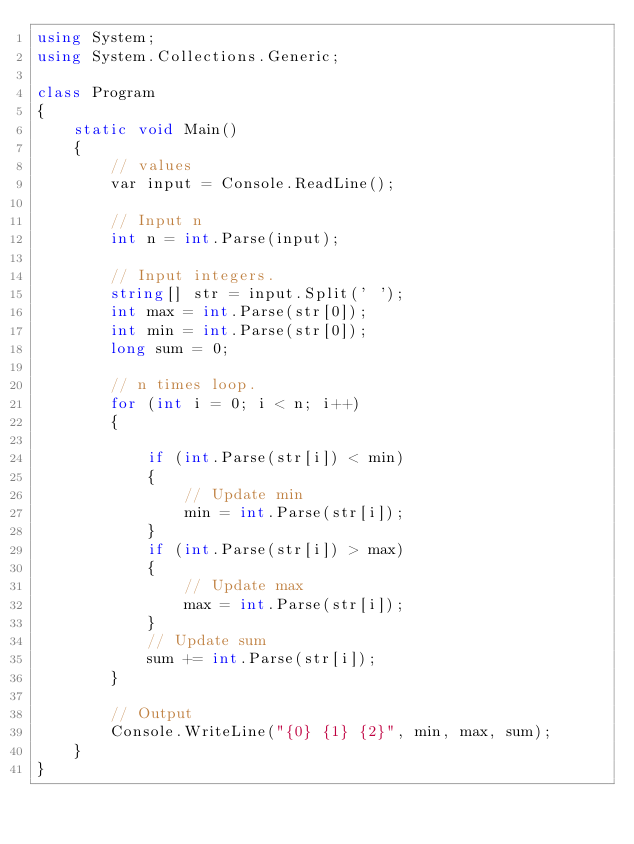<code> <loc_0><loc_0><loc_500><loc_500><_C#_>using System;
using System.Collections.Generic;

class Program
{
    static void Main()
    {
        // values
        var input = Console.ReadLine();

        // Input n
        int n = int.Parse(input);

        // Input integers.
        string[] str = input.Split(' ');
        int max = int.Parse(str[0]);
        int min = int.Parse(str[0]);
        long sum = 0;

        // n times loop.
        for (int i = 0; i < n; i++)
        {

            if (int.Parse(str[i]) < min)
            {
                // Update min
                min = int.Parse(str[i]);
            }
            if (int.Parse(str[i]) > max)
            {
                // Update max
                max = int.Parse(str[i]);
            }
            // Update sum
            sum += int.Parse(str[i]);
        }

        // Output
        Console.WriteLine("{0} {1} {2}", min, max, sum);
    }
}</code> 